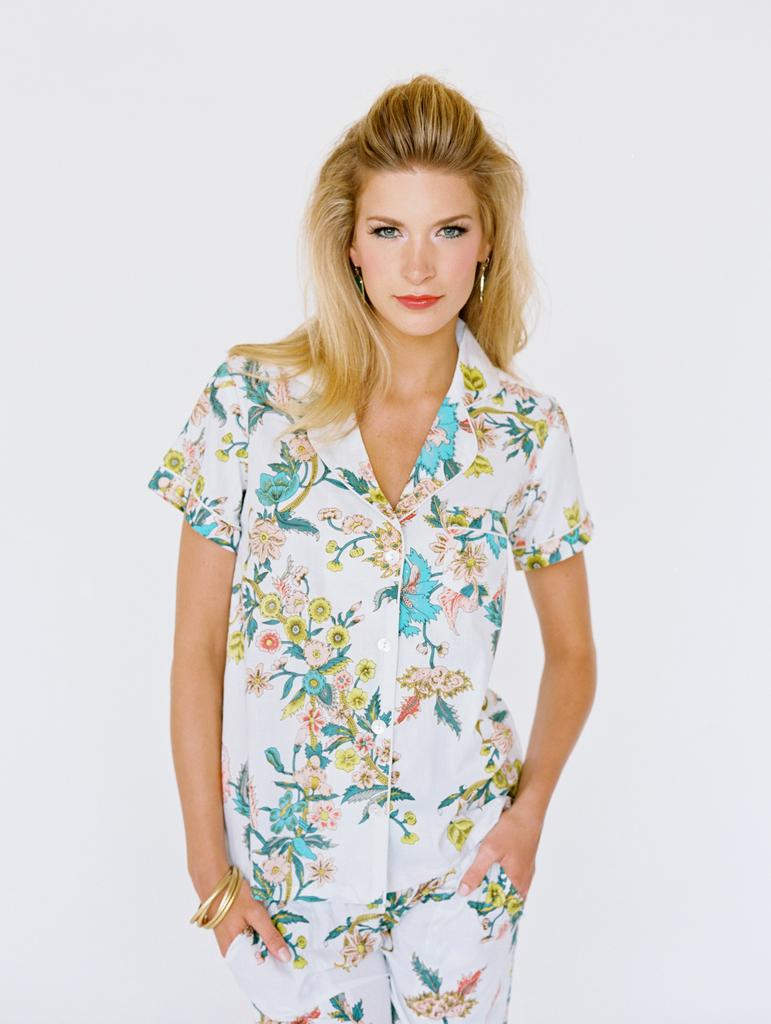What is the main subject of the image? The main subject of the image is a woman. What is the woman wearing in the image? The woman is wearing a shirt, trousers, bangles, and earrings in the image. What is the woman's facial expression in the image? The woman is smiling in the image. What can be seen in the background of the image? There is a white object in the background of the image. What type of badge is the woman wearing in the image? There is no badge visible in the image. What decision is the woman making in the image? The image does not depict the woman making any decision. What journey is the woman embarking on in the image? The image does not show the woman embarking on any journey. 